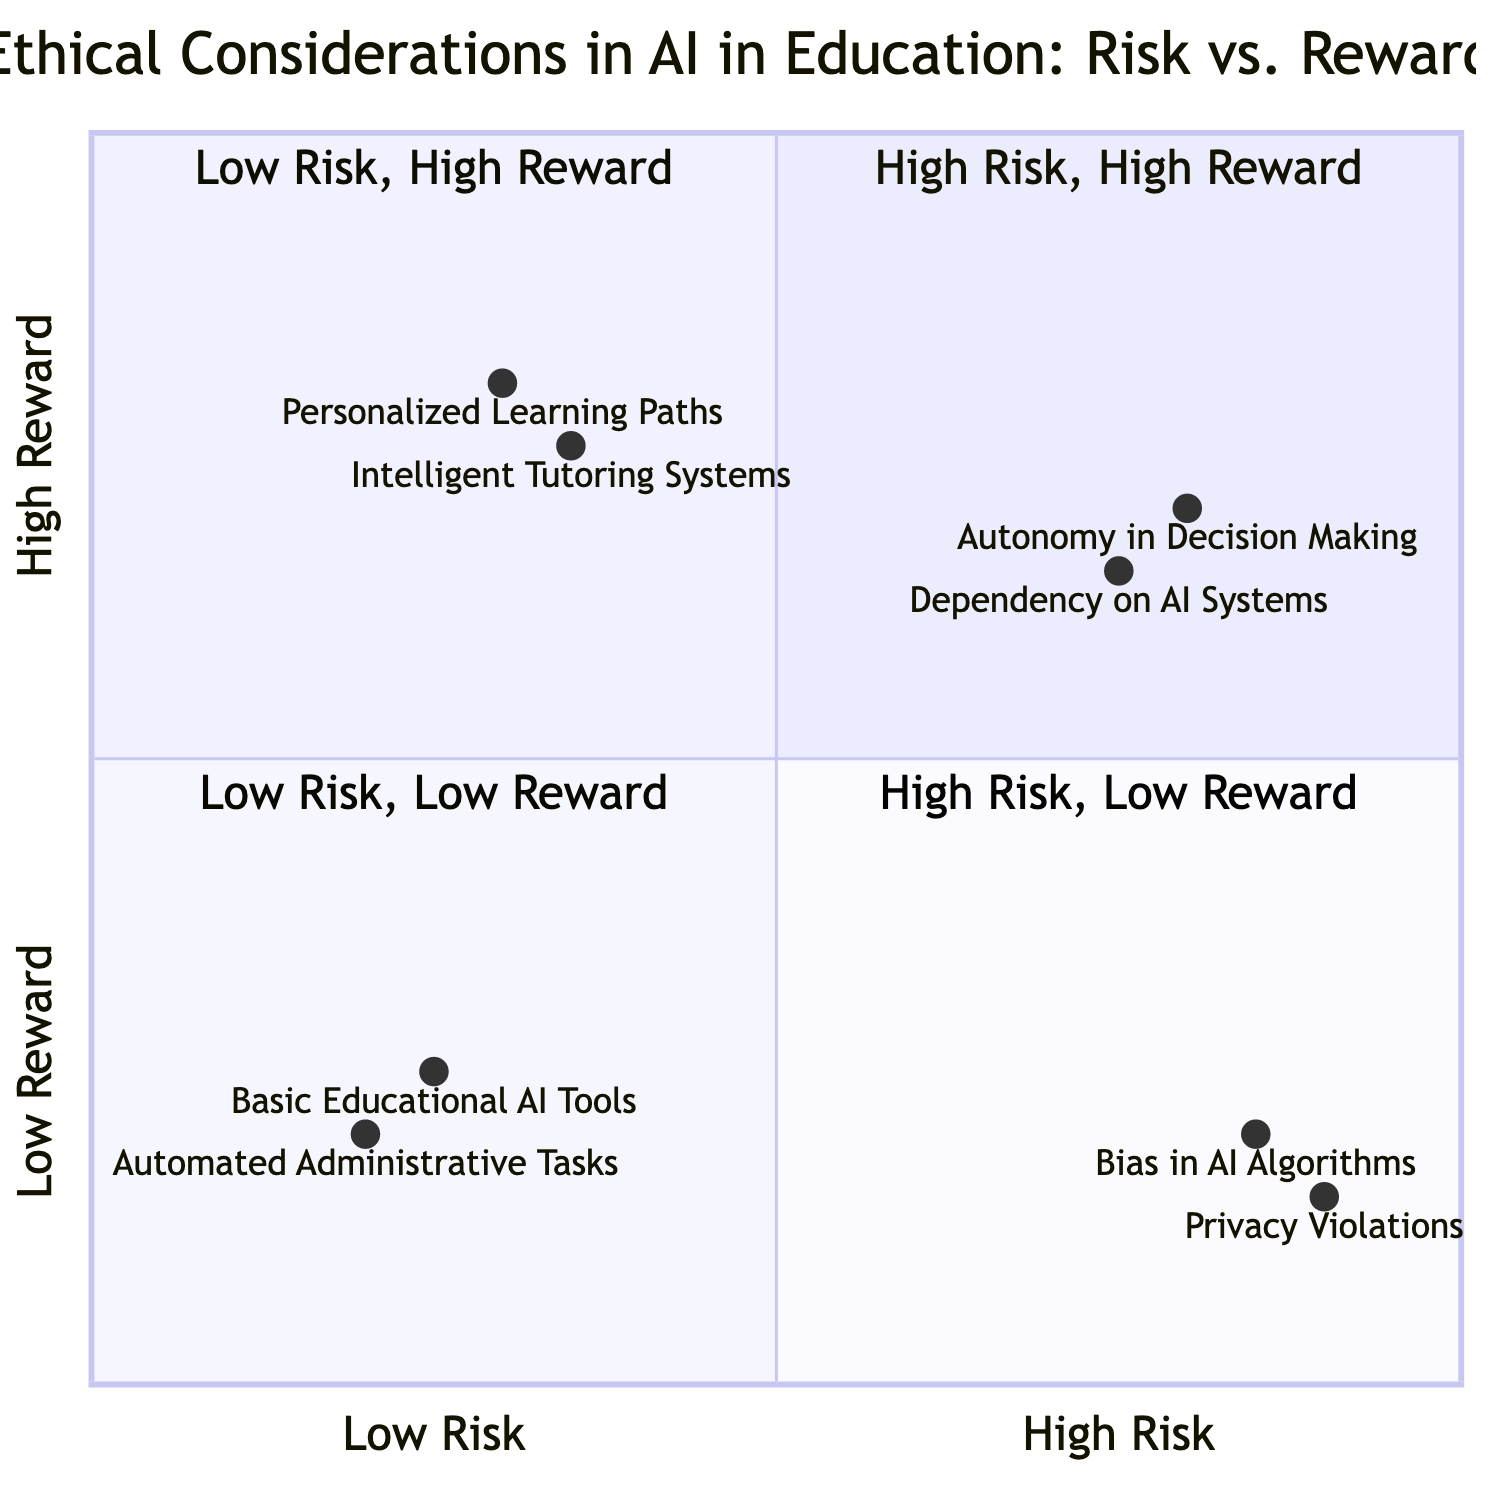What is the position of "Autonomy in Decision Making"? "Autonomy in Decision Making" is positioned at [0.8, 0.7], which corresponds to a high risk and high reward quadrant.
Answer: [0.8, 0.7] How many items are in the "High Risk, Low Reward" quadrant? In the "High Risk, Low Reward" quadrant, there are two items: "Bias in AI Algorithms" and "Privacy Violations."
Answer: 2 Which item has the highest risk? "Privacy Violations" has the highest risk, positioned at 0.9 on the x-axis.
Answer: Privacy Violations What is the lowest reward score in the diagram? The lowest reward score is 0.15 associated with "Privacy Violations," which is indicated on the y-axis.
Answer: 0.15 Which quadrant contains "Personalized Learning Paths"? "Personalized Learning Paths" is located in the "Low Risk, High Reward" quadrant.
Answer: Low Risk, High Reward What is the difference in reward scores between "Intelligent Tutoring Systems" and "Dependency on AI Systems"? "Intelligent Tutoring Systems" has a reward score of 0.75 while "Dependency on AI Systems" has a score of 0.65, resulting in a difference of 0.10 when subtracted.
Answer: 0.10 How many items fall under the "Low Risk, Low Reward" quadrant? There are two items in the "Low Risk, Low Reward" quadrant: "Automated Administrative Tasks" and "Basic Educational AI Tools."
Answer: 2 Which item is the most rewarding under "Low Risk"? The most rewarding item under "Low Risk" is "Personalized Learning Paths" with a reward score of 0.8.
Answer: Personalized Learning Paths What is the x-axis value for "Basic Educational AI Tools"? The x-axis value for "Basic Educational AI Tools" is 0.25, which indicates its risk level.
Answer: 0.25 